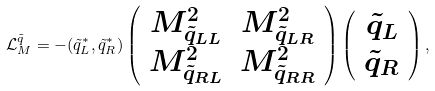<formula> <loc_0><loc_0><loc_500><loc_500>\mathcal { L } ^ { \tilde { q } } _ { M } = - ( \tilde { q } _ { L } ^ { * } , \tilde { q } _ { R } ^ { * } ) \left ( \begin{array} { c c } M _ { \tilde { q } _ { L L } } ^ { 2 } & M _ { \tilde { q } _ { L R } } ^ { 2 } \\ M _ { \tilde { q } _ { R L } } ^ { 2 } & M _ { \tilde { q } _ { R R } } ^ { 2 } \end{array} \right ) \left ( \begin{array} { c } \tilde { q } _ { L } \\ \tilde { q } _ { R } \end{array} \right ) ,</formula> 